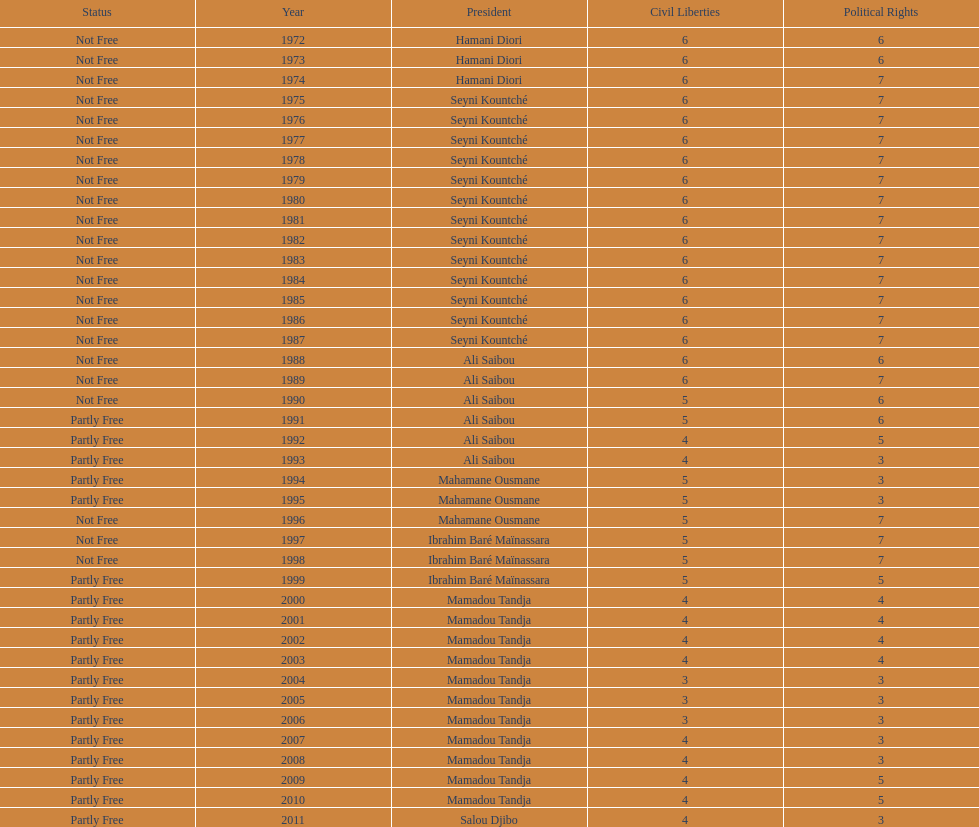How many years was it before the first partly free status? 18. 